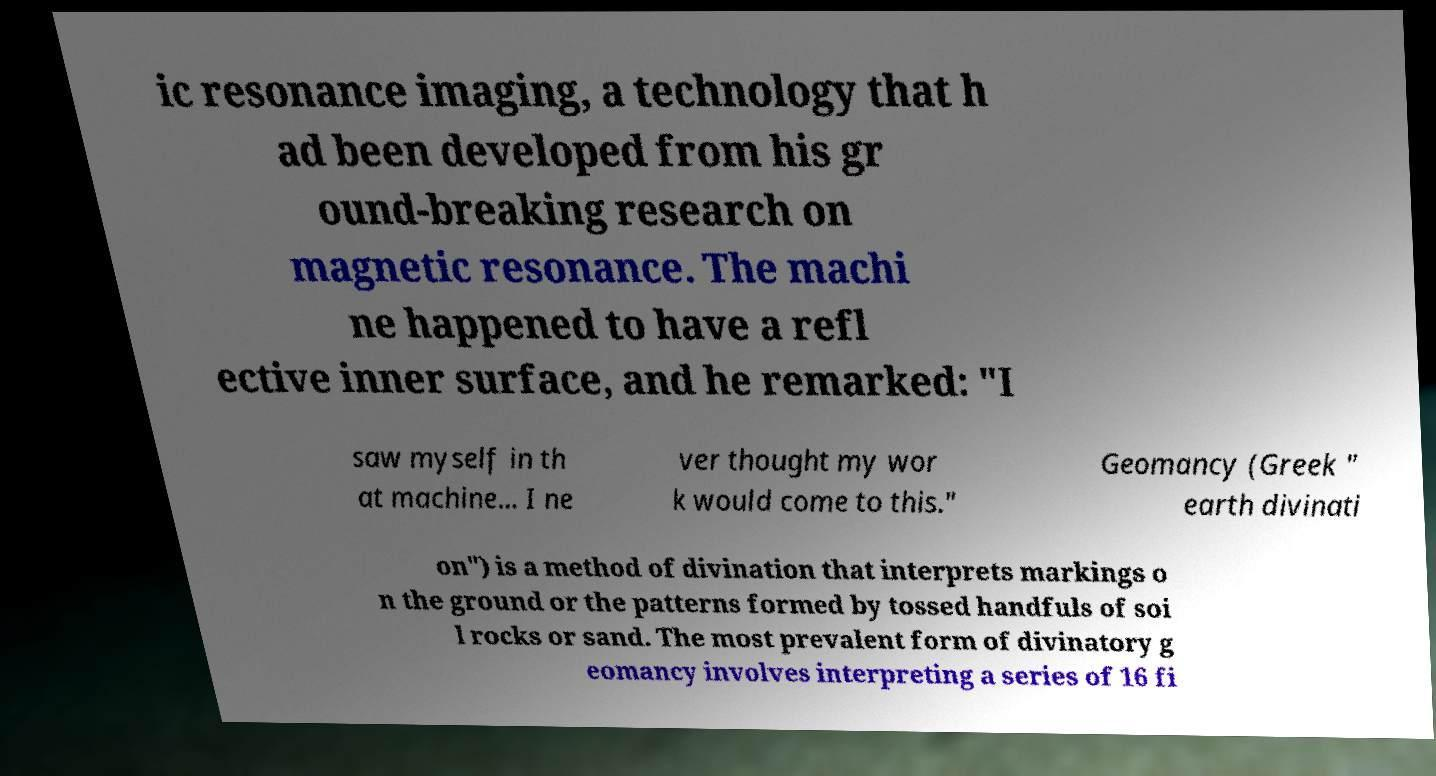Please read and relay the text visible in this image. What does it say? ic resonance imaging, a technology that h ad been developed from his gr ound-breaking research on magnetic resonance. The machi ne happened to have a refl ective inner surface, and he remarked: "I saw myself in th at machine... I ne ver thought my wor k would come to this." Geomancy (Greek " earth divinati on") is a method of divination that interprets markings o n the ground or the patterns formed by tossed handfuls of soi l rocks or sand. The most prevalent form of divinatory g eomancy involves interpreting a series of 16 fi 